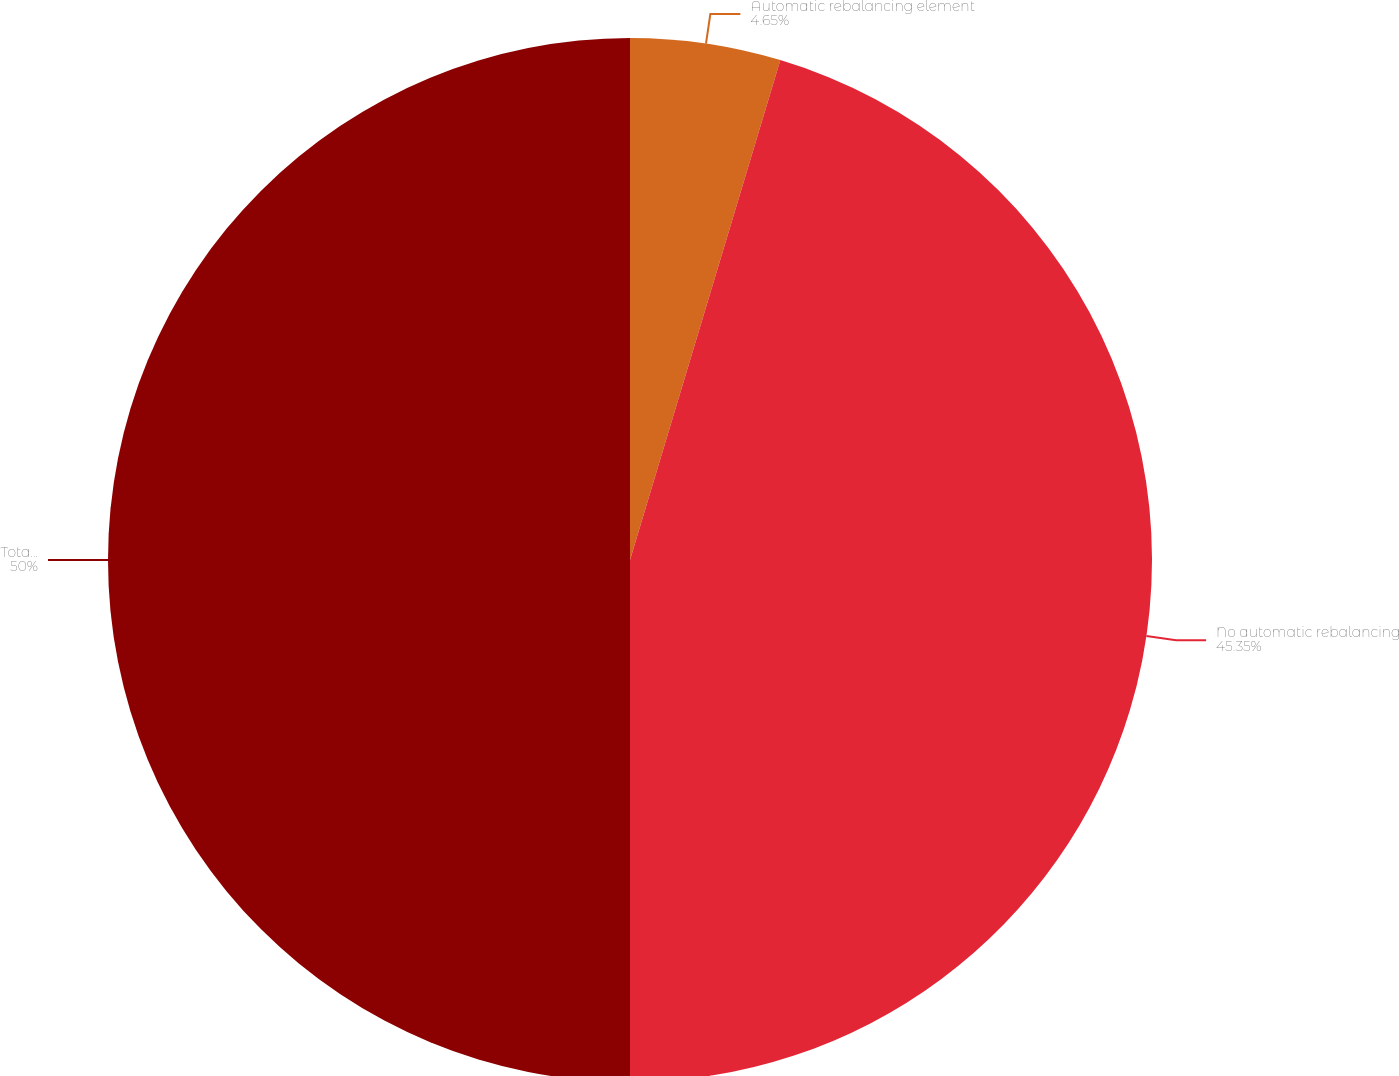Convert chart to OTSL. <chart><loc_0><loc_0><loc_500><loc_500><pie_chart><fcel>Automatic rebalancing element<fcel>No automatic rebalancing<fcel>Total variable annuity account<nl><fcel>4.65%<fcel>45.35%<fcel>50.0%<nl></chart> 